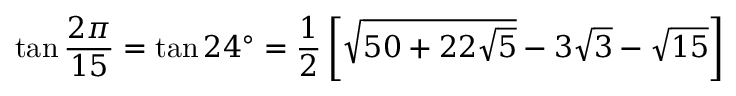Convert formula to latex. <formula><loc_0><loc_0><loc_500><loc_500>\tan { \frac { 2 \pi } { 1 5 } } = \tan 2 4 ^ { \circ } = { \frac { 1 } { 2 } } \left [ { \sqrt { 5 0 + 2 2 { \sqrt { 5 } } } } - 3 { \sqrt { 3 } } - { \sqrt { 1 5 } } \right ]</formula> 